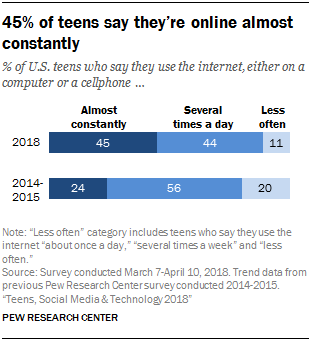Give some essential details in this illustration. According to a survey conducted in 2018, 0.44% of teenagers reported that they are online several times a day. The total of both "Less often" bars is 1460. Multiplying this number by the value of the largest bar, which is 220, results in a product of 31,280. The result of this calculation is 1736. 